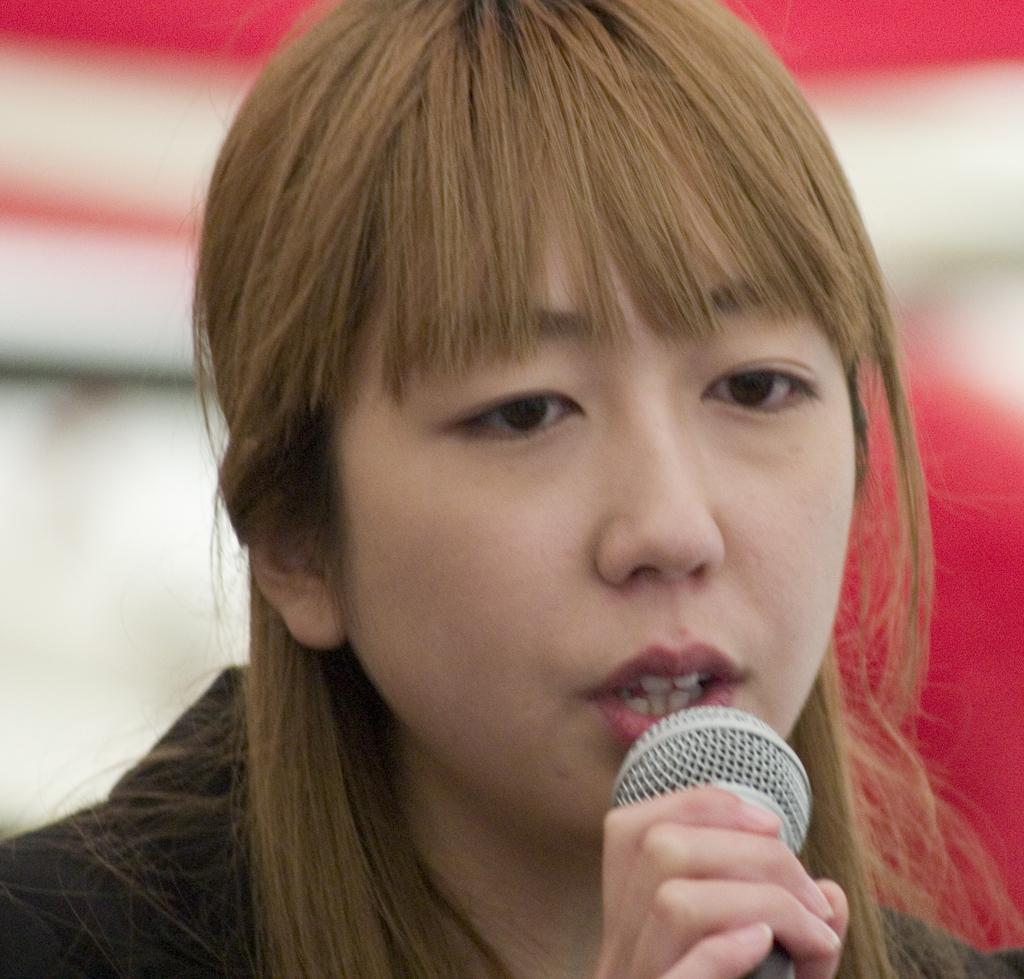Who is the main subject in the image? There is a woman in the image. What is the woman holding in the image? The woman is holding a microphone. What might the woman be doing with the microphone? It appears that the woman is talking, as she is holding a microphone. How many trains can be seen in the image? There are no trains present in the image. What type of bell is visible in the image? There is no bell present in the image. 